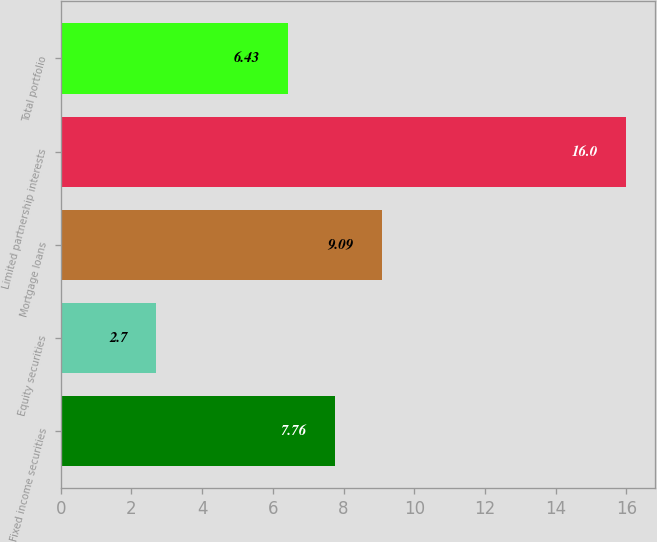Convert chart to OTSL. <chart><loc_0><loc_0><loc_500><loc_500><bar_chart><fcel>Fixed income securities<fcel>Equity securities<fcel>Mortgage loans<fcel>Limited partnership interests<fcel>Total portfolio<nl><fcel>7.76<fcel>2.7<fcel>9.09<fcel>16<fcel>6.43<nl></chart> 